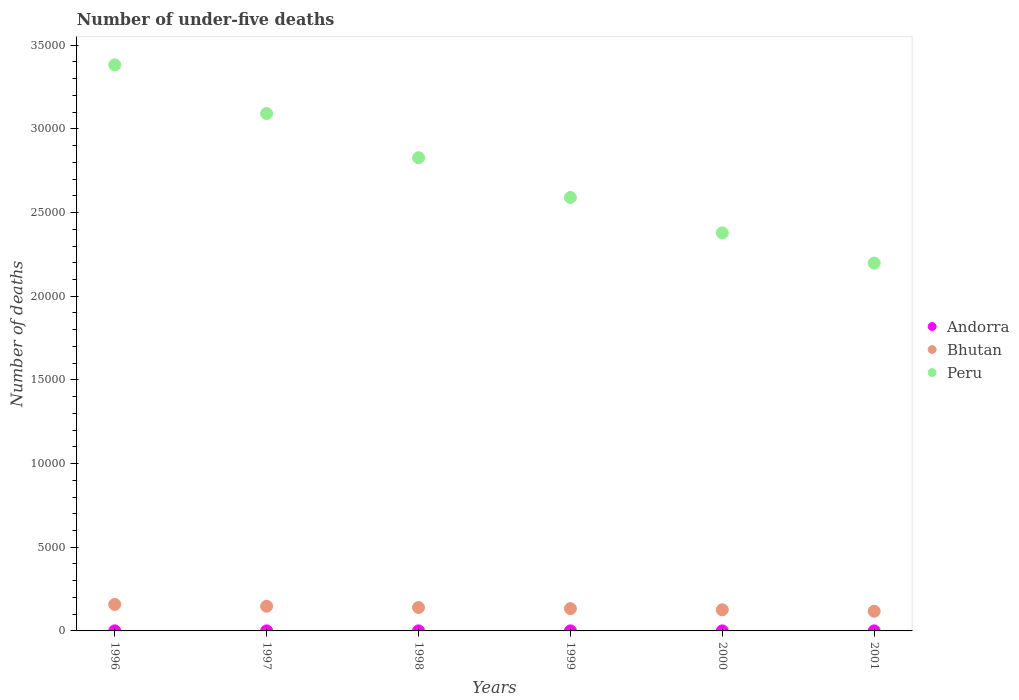How many different coloured dotlines are there?
Offer a very short reply. 3. Is the number of dotlines equal to the number of legend labels?
Ensure brevity in your answer.  Yes. Across all years, what is the maximum number of under-five deaths in Peru?
Make the answer very short. 3.38e+04. Across all years, what is the minimum number of under-five deaths in Peru?
Your answer should be compact. 2.20e+04. What is the total number of under-five deaths in Andorra in the graph?
Your answer should be very brief. 20. What is the difference between the number of under-five deaths in Peru in 1997 and that in 1998?
Your answer should be very brief. 2642. What is the difference between the number of under-five deaths in Peru in 1997 and the number of under-five deaths in Andorra in 2000?
Offer a terse response. 3.09e+04. What is the average number of under-five deaths in Andorra per year?
Provide a short and direct response. 3.33. In the year 2001, what is the difference between the number of under-five deaths in Bhutan and number of under-five deaths in Peru?
Your response must be concise. -2.08e+04. What is the ratio of the number of under-five deaths in Peru in 1996 to that in 1999?
Offer a terse response. 1.31. Is the number of under-five deaths in Peru in 1997 less than that in 2000?
Ensure brevity in your answer.  No. What is the difference between the highest and the second highest number of under-five deaths in Peru?
Offer a very short reply. 2906. In how many years, is the number of under-five deaths in Peru greater than the average number of under-five deaths in Peru taken over all years?
Keep it short and to the point. 3. Is the number of under-five deaths in Peru strictly greater than the number of under-five deaths in Andorra over the years?
Provide a short and direct response. Yes. Are the values on the major ticks of Y-axis written in scientific E-notation?
Make the answer very short. No. What is the title of the graph?
Make the answer very short. Number of under-five deaths. What is the label or title of the Y-axis?
Offer a terse response. Number of deaths. What is the Number of deaths of Bhutan in 1996?
Offer a very short reply. 1583. What is the Number of deaths of Peru in 1996?
Your response must be concise. 3.38e+04. What is the Number of deaths of Bhutan in 1997?
Provide a succinct answer. 1474. What is the Number of deaths in Peru in 1997?
Make the answer very short. 3.09e+04. What is the Number of deaths in Bhutan in 1998?
Provide a succinct answer. 1399. What is the Number of deaths of Peru in 1998?
Give a very brief answer. 2.83e+04. What is the Number of deaths of Bhutan in 1999?
Make the answer very short. 1333. What is the Number of deaths in Peru in 1999?
Your response must be concise. 2.59e+04. What is the Number of deaths in Andorra in 2000?
Offer a very short reply. 3. What is the Number of deaths in Bhutan in 2000?
Give a very brief answer. 1263. What is the Number of deaths in Peru in 2000?
Ensure brevity in your answer.  2.38e+04. What is the Number of deaths in Andorra in 2001?
Offer a terse response. 3. What is the Number of deaths in Bhutan in 2001?
Keep it short and to the point. 1175. What is the Number of deaths in Peru in 2001?
Ensure brevity in your answer.  2.20e+04. Across all years, what is the maximum Number of deaths of Bhutan?
Make the answer very short. 1583. Across all years, what is the maximum Number of deaths of Peru?
Offer a terse response. 3.38e+04. Across all years, what is the minimum Number of deaths in Andorra?
Provide a short and direct response. 3. Across all years, what is the minimum Number of deaths in Bhutan?
Your answer should be compact. 1175. Across all years, what is the minimum Number of deaths of Peru?
Provide a short and direct response. 2.20e+04. What is the total Number of deaths in Bhutan in the graph?
Offer a terse response. 8227. What is the total Number of deaths in Peru in the graph?
Offer a terse response. 1.65e+05. What is the difference between the Number of deaths in Andorra in 1996 and that in 1997?
Your response must be concise. 0. What is the difference between the Number of deaths in Bhutan in 1996 and that in 1997?
Your answer should be very brief. 109. What is the difference between the Number of deaths of Peru in 1996 and that in 1997?
Ensure brevity in your answer.  2906. What is the difference between the Number of deaths of Bhutan in 1996 and that in 1998?
Offer a very short reply. 184. What is the difference between the Number of deaths in Peru in 1996 and that in 1998?
Ensure brevity in your answer.  5548. What is the difference between the Number of deaths of Bhutan in 1996 and that in 1999?
Your answer should be very brief. 250. What is the difference between the Number of deaths in Peru in 1996 and that in 1999?
Give a very brief answer. 7923. What is the difference between the Number of deaths in Bhutan in 1996 and that in 2000?
Give a very brief answer. 320. What is the difference between the Number of deaths of Peru in 1996 and that in 2000?
Your response must be concise. 1.00e+04. What is the difference between the Number of deaths in Bhutan in 1996 and that in 2001?
Provide a succinct answer. 408. What is the difference between the Number of deaths in Peru in 1996 and that in 2001?
Keep it short and to the point. 1.18e+04. What is the difference between the Number of deaths of Andorra in 1997 and that in 1998?
Your answer should be compact. 1. What is the difference between the Number of deaths of Peru in 1997 and that in 1998?
Offer a very short reply. 2642. What is the difference between the Number of deaths of Bhutan in 1997 and that in 1999?
Offer a terse response. 141. What is the difference between the Number of deaths in Peru in 1997 and that in 1999?
Make the answer very short. 5017. What is the difference between the Number of deaths of Bhutan in 1997 and that in 2000?
Offer a terse response. 211. What is the difference between the Number of deaths of Peru in 1997 and that in 2000?
Keep it short and to the point. 7133. What is the difference between the Number of deaths of Bhutan in 1997 and that in 2001?
Your answer should be very brief. 299. What is the difference between the Number of deaths in Peru in 1997 and that in 2001?
Provide a succinct answer. 8938. What is the difference between the Number of deaths of Bhutan in 1998 and that in 1999?
Keep it short and to the point. 66. What is the difference between the Number of deaths in Peru in 1998 and that in 1999?
Provide a succinct answer. 2375. What is the difference between the Number of deaths of Bhutan in 1998 and that in 2000?
Ensure brevity in your answer.  136. What is the difference between the Number of deaths of Peru in 1998 and that in 2000?
Provide a succinct answer. 4491. What is the difference between the Number of deaths in Bhutan in 1998 and that in 2001?
Offer a very short reply. 224. What is the difference between the Number of deaths in Peru in 1998 and that in 2001?
Offer a terse response. 6296. What is the difference between the Number of deaths in Peru in 1999 and that in 2000?
Your answer should be very brief. 2116. What is the difference between the Number of deaths of Bhutan in 1999 and that in 2001?
Offer a terse response. 158. What is the difference between the Number of deaths in Peru in 1999 and that in 2001?
Provide a short and direct response. 3921. What is the difference between the Number of deaths in Peru in 2000 and that in 2001?
Give a very brief answer. 1805. What is the difference between the Number of deaths in Andorra in 1996 and the Number of deaths in Bhutan in 1997?
Offer a terse response. -1470. What is the difference between the Number of deaths of Andorra in 1996 and the Number of deaths of Peru in 1997?
Make the answer very short. -3.09e+04. What is the difference between the Number of deaths in Bhutan in 1996 and the Number of deaths in Peru in 1997?
Offer a terse response. -2.93e+04. What is the difference between the Number of deaths of Andorra in 1996 and the Number of deaths of Bhutan in 1998?
Offer a terse response. -1395. What is the difference between the Number of deaths of Andorra in 1996 and the Number of deaths of Peru in 1998?
Make the answer very short. -2.83e+04. What is the difference between the Number of deaths of Bhutan in 1996 and the Number of deaths of Peru in 1998?
Provide a succinct answer. -2.67e+04. What is the difference between the Number of deaths in Andorra in 1996 and the Number of deaths in Bhutan in 1999?
Keep it short and to the point. -1329. What is the difference between the Number of deaths of Andorra in 1996 and the Number of deaths of Peru in 1999?
Provide a succinct answer. -2.59e+04. What is the difference between the Number of deaths in Bhutan in 1996 and the Number of deaths in Peru in 1999?
Ensure brevity in your answer.  -2.43e+04. What is the difference between the Number of deaths in Andorra in 1996 and the Number of deaths in Bhutan in 2000?
Provide a succinct answer. -1259. What is the difference between the Number of deaths in Andorra in 1996 and the Number of deaths in Peru in 2000?
Your answer should be compact. -2.38e+04. What is the difference between the Number of deaths of Bhutan in 1996 and the Number of deaths of Peru in 2000?
Ensure brevity in your answer.  -2.22e+04. What is the difference between the Number of deaths in Andorra in 1996 and the Number of deaths in Bhutan in 2001?
Keep it short and to the point. -1171. What is the difference between the Number of deaths of Andorra in 1996 and the Number of deaths of Peru in 2001?
Give a very brief answer. -2.20e+04. What is the difference between the Number of deaths of Bhutan in 1996 and the Number of deaths of Peru in 2001?
Provide a short and direct response. -2.04e+04. What is the difference between the Number of deaths in Andorra in 1997 and the Number of deaths in Bhutan in 1998?
Keep it short and to the point. -1395. What is the difference between the Number of deaths in Andorra in 1997 and the Number of deaths in Peru in 1998?
Your answer should be compact. -2.83e+04. What is the difference between the Number of deaths of Bhutan in 1997 and the Number of deaths of Peru in 1998?
Keep it short and to the point. -2.68e+04. What is the difference between the Number of deaths of Andorra in 1997 and the Number of deaths of Bhutan in 1999?
Give a very brief answer. -1329. What is the difference between the Number of deaths of Andorra in 1997 and the Number of deaths of Peru in 1999?
Offer a terse response. -2.59e+04. What is the difference between the Number of deaths of Bhutan in 1997 and the Number of deaths of Peru in 1999?
Your answer should be very brief. -2.44e+04. What is the difference between the Number of deaths of Andorra in 1997 and the Number of deaths of Bhutan in 2000?
Provide a succinct answer. -1259. What is the difference between the Number of deaths in Andorra in 1997 and the Number of deaths in Peru in 2000?
Offer a very short reply. -2.38e+04. What is the difference between the Number of deaths of Bhutan in 1997 and the Number of deaths of Peru in 2000?
Provide a succinct answer. -2.23e+04. What is the difference between the Number of deaths of Andorra in 1997 and the Number of deaths of Bhutan in 2001?
Your answer should be compact. -1171. What is the difference between the Number of deaths in Andorra in 1997 and the Number of deaths in Peru in 2001?
Offer a very short reply. -2.20e+04. What is the difference between the Number of deaths of Bhutan in 1997 and the Number of deaths of Peru in 2001?
Keep it short and to the point. -2.05e+04. What is the difference between the Number of deaths in Andorra in 1998 and the Number of deaths in Bhutan in 1999?
Provide a succinct answer. -1330. What is the difference between the Number of deaths of Andorra in 1998 and the Number of deaths of Peru in 1999?
Offer a terse response. -2.59e+04. What is the difference between the Number of deaths of Bhutan in 1998 and the Number of deaths of Peru in 1999?
Offer a very short reply. -2.45e+04. What is the difference between the Number of deaths of Andorra in 1998 and the Number of deaths of Bhutan in 2000?
Ensure brevity in your answer.  -1260. What is the difference between the Number of deaths in Andorra in 1998 and the Number of deaths in Peru in 2000?
Your answer should be very brief. -2.38e+04. What is the difference between the Number of deaths in Bhutan in 1998 and the Number of deaths in Peru in 2000?
Offer a terse response. -2.24e+04. What is the difference between the Number of deaths of Andorra in 1998 and the Number of deaths of Bhutan in 2001?
Offer a very short reply. -1172. What is the difference between the Number of deaths of Andorra in 1998 and the Number of deaths of Peru in 2001?
Provide a succinct answer. -2.20e+04. What is the difference between the Number of deaths in Bhutan in 1998 and the Number of deaths in Peru in 2001?
Your answer should be compact. -2.06e+04. What is the difference between the Number of deaths in Andorra in 1999 and the Number of deaths in Bhutan in 2000?
Your response must be concise. -1260. What is the difference between the Number of deaths of Andorra in 1999 and the Number of deaths of Peru in 2000?
Your answer should be compact. -2.38e+04. What is the difference between the Number of deaths of Bhutan in 1999 and the Number of deaths of Peru in 2000?
Give a very brief answer. -2.25e+04. What is the difference between the Number of deaths in Andorra in 1999 and the Number of deaths in Bhutan in 2001?
Give a very brief answer. -1172. What is the difference between the Number of deaths in Andorra in 1999 and the Number of deaths in Peru in 2001?
Make the answer very short. -2.20e+04. What is the difference between the Number of deaths of Bhutan in 1999 and the Number of deaths of Peru in 2001?
Provide a short and direct response. -2.06e+04. What is the difference between the Number of deaths of Andorra in 2000 and the Number of deaths of Bhutan in 2001?
Your answer should be very brief. -1172. What is the difference between the Number of deaths in Andorra in 2000 and the Number of deaths in Peru in 2001?
Provide a short and direct response. -2.20e+04. What is the difference between the Number of deaths of Bhutan in 2000 and the Number of deaths of Peru in 2001?
Your response must be concise. -2.07e+04. What is the average Number of deaths of Andorra per year?
Offer a terse response. 3.33. What is the average Number of deaths of Bhutan per year?
Provide a succinct answer. 1371.17. What is the average Number of deaths of Peru per year?
Give a very brief answer. 2.74e+04. In the year 1996, what is the difference between the Number of deaths in Andorra and Number of deaths in Bhutan?
Offer a terse response. -1579. In the year 1996, what is the difference between the Number of deaths in Andorra and Number of deaths in Peru?
Your answer should be compact. -3.38e+04. In the year 1996, what is the difference between the Number of deaths of Bhutan and Number of deaths of Peru?
Offer a terse response. -3.22e+04. In the year 1997, what is the difference between the Number of deaths of Andorra and Number of deaths of Bhutan?
Give a very brief answer. -1470. In the year 1997, what is the difference between the Number of deaths in Andorra and Number of deaths in Peru?
Offer a terse response. -3.09e+04. In the year 1997, what is the difference between the Number of deaths in Bhutan and Number of deaths in Peru?
Offer a very short reply. -2.94e+04. In the year 1998, what is the difference between the Number of deaths of Andorra and Number of deaths of Bhutan?
Keep it short and to the point. -1396. In the year 1998, what is the difference between the Number of deaths in Andorra and Number of deaths in Peru?
Keep it short and to the point. -2.83e+04. In the year 1998, what is the difference between the Number of deaths in Bhutan and Number of deaths in Peru?
Keep it short and to the point. -2.69e+04. In the year 1999, what is the difference between the Number of deaths in Andorra and Number of deaths in Bhutan?
Make the answer very short. -1330. In the year 1999, what is the difference between the Number of deaths of Andorra and Number of deaths of Peru?
Give a very brief answer. -2.59e+04. In the year 1999, what is the difference between the Number of deaths of Bhutan and Number of deaths of Peru?
Your answer should be compact. -2.46e+04. In the year 2000, what is the difference between the Number of deaths in Andorra and Number of deaths in Bhutan?
Offer a very short reply. -1260. In the year 2000, what is the difference between the Number of deaths of Andorra and Number of deaths of Peru?
Ensure brevity in your answer.  -2.38e+04. In the year 2000, what is the difference between the Number of deaths of Bhutan and Number of deaths of Peru?
Provide a short and direct response. -2.25e+04. In the year 2001, what is the difference between the Number of deaths of Andorra and Number of deaths of Bhutan?
Provide a short and direct response. -1172. In the year 2001, what is the difference between the Number of deaths of Andorra and Number of deaths of Peru?
Keep it short and to the point. -2.20e+04. In the year 2001, what is the difference between the Number of deaths of Bhutan and Number of deaths of Peru?
Offer a terse response. -2.08e+04. What is the ratio of the Number of deaths of Bhutan in 1996 to that in 1997?
Keep it short and to the point. 1.07. What is the ratio of the Number of deaths in Peru in 1996 to that in 1997?
Ensure brevity in your answer.  1.09. What is the ratio of the Number of deaths in Bhutan in 1996 to that in 1998?
Make the answer very short. 1.13. What is the ratio of the Number of deaths of Peru in 1996 to that in 1998?
Offer a terse response. 1.2. What is the ratio of the Number of deaths in Andorra in 1996 to that in 1999?
Make the answer very short. 1.33. What is the ratio of the Number of deaths in Bhutan in 1996 to that in 1999?
Give a very brief answer. 1.19. What is the ratio of the Number of deaths in Peru in 1996 to that in 1999?
Provide a succinct answer. 1.31. What is the ratio of the Number of deaths in Andorra in 1996 to that in 2000?
Your response must be concise. 1.33. What is the ratio of the Number of deaths of Bhutan in 1996 to that in 2000?
Your response must be concise. 1.25. What is the ratio of the Number of deaths in Peru in 1996 to that in 2000?
Give a very brief answer. 1.42. What is the ratio of the Number of deaths of Andorra in 1996 to that in 2001?
Provide a succinct answer. 1.33. What is the ratio of the Number of deaths of Bhutan in 1996 to that in 2001?
Keep it short and to the point. 1.35. What is the ratio of the Number of deaths of Peru in 1996 to that in 2001?
Provide a short and direct response. 1.54. What is the ratio of the Number of deaths of Bhutan in 1997 to that in 1998?
Give a very brief answer. 1.05. What is the ratio of the Number of deaths in Peru in 1997 to that in 1998?
Provide a short and direct response. 1.09. What is the ratio of the Number of deaths in Bhutan in 1997 to that in 1999?
Make the answer very short. 1.11. What is the ratio of the Number of deaths in Peru in 1997 to that in 1999?
Provide a succinct answer. 1.19. What is the ratio of the Number of deaths in Andorra in 1997 to that in 2000?
Ensure brevity in your answer.  1.33. What is the ratio of the Number of deaths of Bhutan in 1997 to that in 2000?
Your answer should be compact. 1.17. What is the ratio of the Number of deaths of Peru in 1997 to that in 2000?
Keep it short and to the point. 1.3. What is the ratio of the Number of deaths of Bhutan in 1997 to that in 2001?
Your answer should be compact. 1.25. What is the ratio of the Number of deaths of Peru in 1997 to that in 2001?
Ensure brevity in your answer.  1.41. What is the ratio of the Number of deaths of Andorra in 1998 to that in 1999?
Give a very brief answer. 1. What is the ratio of the Number of deaths in Bhutan in 1998 to that in 1999?
Provide a short and direct response. 1.05. What is the ratio of the Number of deaths of Peru in 1998 to that in 1999?
Your answer should be compact. 1.09. What is the ratio of the Number of deaths of Andorra in 1998 to that in 2000?
Your response must be concise. 1. What is the ratio of the Number of deaths in Bhutan in 1998 to that in 2000?
Ensure brevity in your answer.  1.11. What is the ratio of the Number of deaths in Peru in 1998 to that in 2000?
Ensure brevity in your answer.  1.19. What is the ratio of the Number of deaths of Andorra in 1998 to that in 2001?
Your answer should be very brief. 1. What is the ratio of the Number of deaths of Bhutan in 1998 to that in 2001?
Your response must be concise. 1.19. What is the ratio of the Number of deaths of Peru in 1998 to that in 2001?
Offer a very short reply. 1.29. What is the ratio of the Number of deaths of Andorra in 1999 to that in 2000?
Offer a terse response. 1. What is the ratio of the Number of deaths in Bhutan in 1999 to that in 2000?
Your answer should be compact. 1.06. What is the ratio of the Number of deaths of Peru in 1999 to that in 2000?
Make the answer very short. 1.09. What is the ratio of the Number of deaths in Bhutan in 1999 to that in 2001?
Your answer should be compact. 1.13. What is the ratio of the Number of deaths in Peru in 1999 to that in 2001?
Offer a very short reply. 1.18. What is the ratio of the Number of deaths in Andorra in 2000 to that in 2001?
Give a very brief answer. 1. What is the ratio of the Number of deaths of Bhutan in 2000 to that in 2001?
Provide a succinct answer. 1.07. What is the ratio of the Number of deaths in Peru in 2000 to that in 2001?
Give a very brief answer. 1.08. What is the difference between the highest and the second highest Number of deaths of Andorra?
Offer a terse response. 0. What is the difference between the highest and the second highest Number of deaths in Bhutan?
Keep it short and to the point. 109. What is the difference between the highest and the second highest Number of deaths in Peru?
Provide a short and direct response. 2906. What is the difference between the highest and the lowest Number of deaths in Bhutan?
Keep it short and to the point. 408. What is the difference between the highest and the lowest Number of deaths of Peru?
Keep it short and to the point. 1.18e+04. 